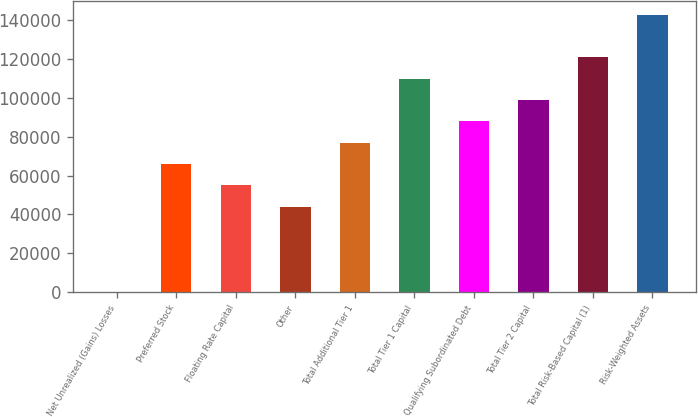<chart> <loc_0><loc_0><loc_500><loc_500><bar_chart><fcel>Net Unrealized (Gains) Losses<fcel>Preferred Stock<fcel>Floating Rate Capital<fcel>Other<fcel>Total Additional Tier 1<fcel>Total Tier 1 Capital<fcel>Qualifying Subordinated Debt<fcel>Total Tier 2 Capital<fcel>Total Risk-Based Capital (1)<fcel>Risk-Weighted Assets<nl><fcel>3.8<fcel>65969.4<fcel>54975.2<fcel>43980.9<fcel>76963.7<fcel>109946<fcel>87958<fcel>98952.2<fcel>120941<fcel>142929<nl></chart> 